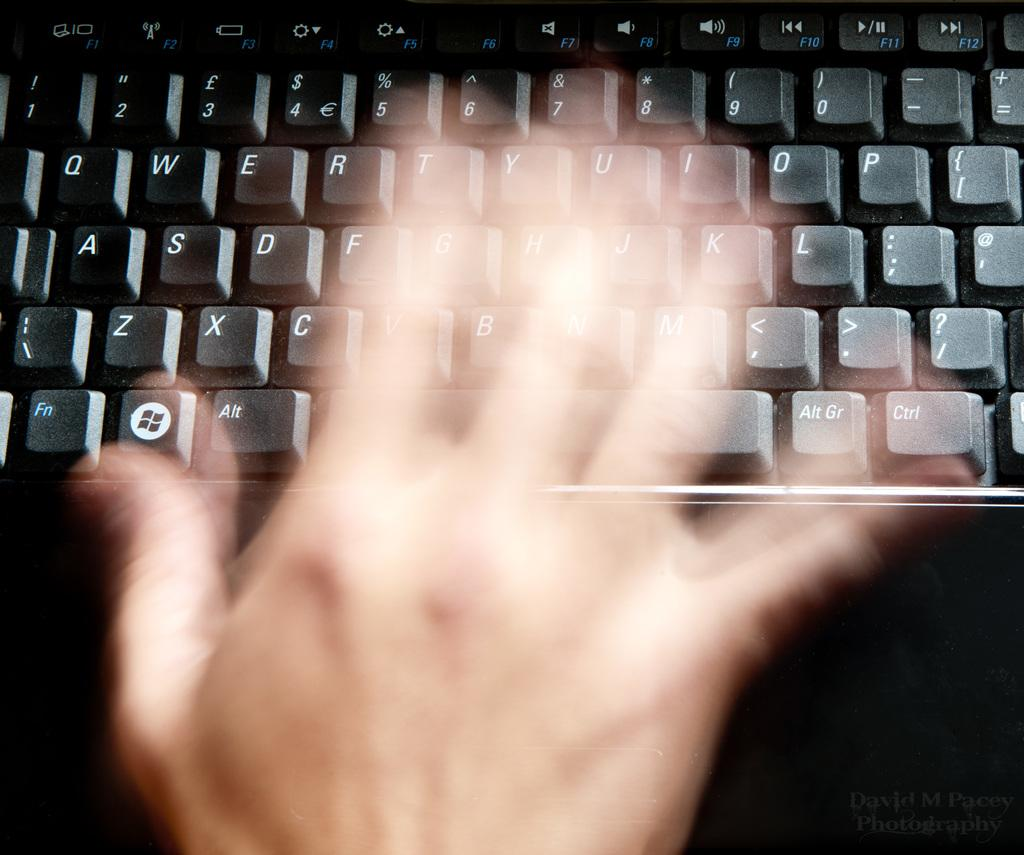<image>
Present a compact description of the photo's key features. a blurred picture of a keyboard with the letter P on the top left 